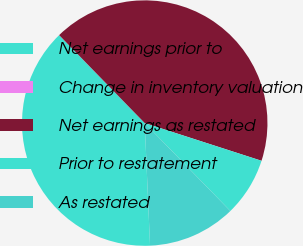Convert chart. <chart><loc_0><loc_0><loc_500><loc_500><pie_chart><fcel>Net earnings prior to<fcel>Change in inventory valuation<fcel>Net earnings as restated<fcel>Prior to restatement<fcel>As restated<nl><fcel>38.4%<fcel>0.01%<fcel>42.26%<fcel>7.74%<fcel>11.6%<nl></chart> 